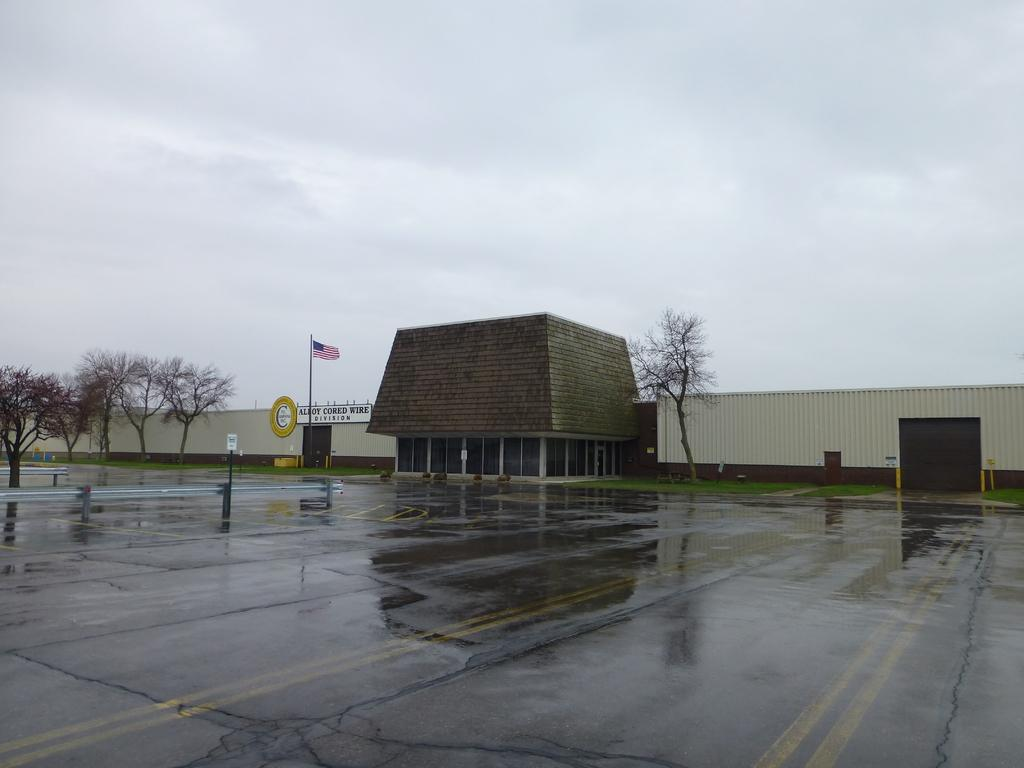What type of vegetation can be seen in the image? There are trees and grass in the image. What structures are present in the image? There are poles, boards, doors, and a wall in the image. What objects can be seen on the wall? There are glasses on the wall in the image. What is visible in the background of the image? The sky is visible in the background of the image. How many clovers are growing in the garden in the image? There is no garden or clover present in the image. What type of can is visible in the image? There is no can present in the image. 